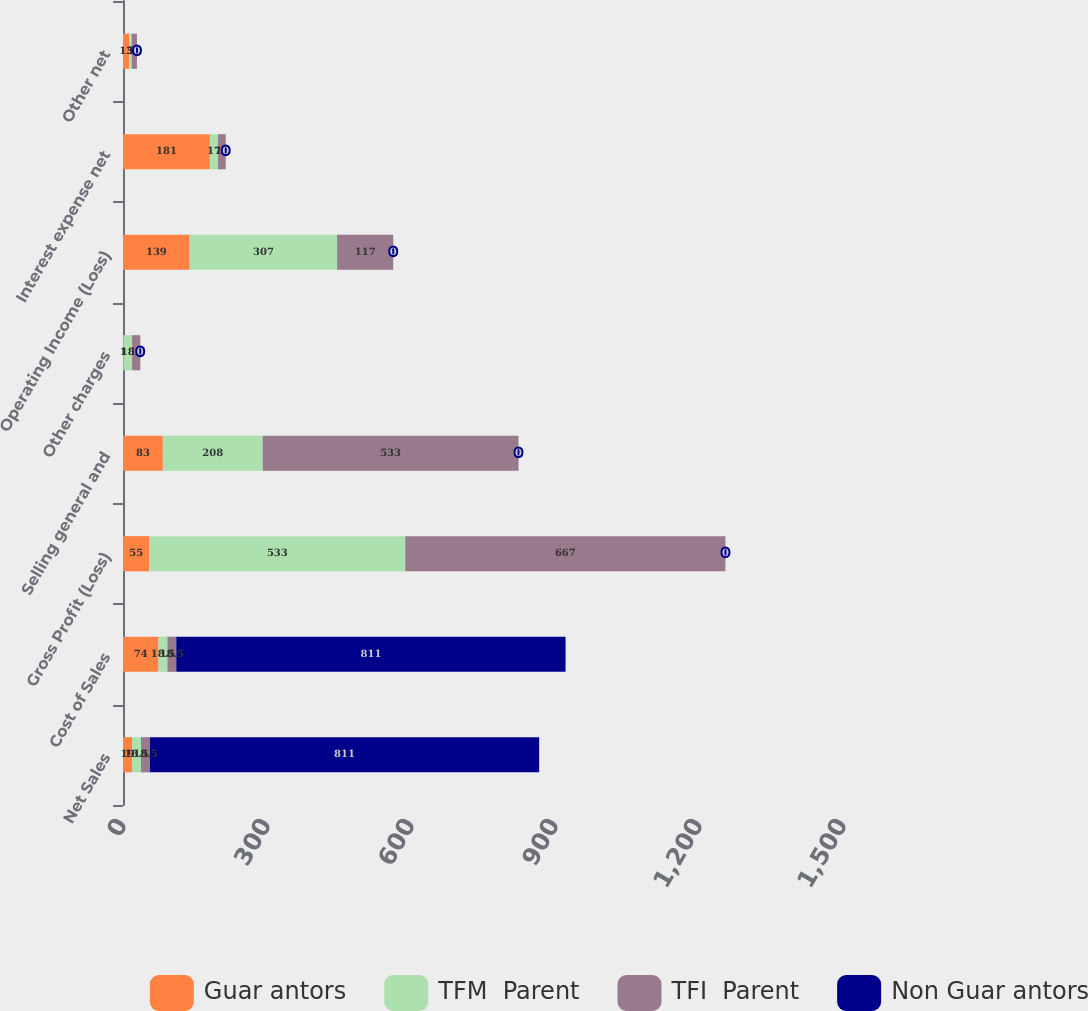<chart> <loc_0><loc_0><loc_500><loc_500><stacked_bar_chart><ecel><fcel>Net Sales<fcel>Cost of Sales<fcel>Gross Profit (Loss)<fcel>Selling general and<fcel>Other charges<fcel>Operating Income (Loss)<fcel>Interest expense net<fcel>Other net<nl><fcel>Guar antors<fcel>19<fcel>74<fcel>55<fcel>83<fcel>1<fcel>139<fcel>181<fcel>13<nl><fcel>TFM  Parent<fcel>18.5<fcel>18.5<fcel>533<fcel>208<fcel>18<fcel>307<fcel>17<fcel>5<nl><fcel>TFI  Parent<fcel>18.5<fcel>18.5<fcel>667<fcel>533<fcel>17<fcel>117<fcel>16<fcel>11<nl><fcel>Non Guar antors<fcel>811<fcel>811<fcel>0<fcel>0<fcel>0<fcel>0<fcel>0<fcel>0<nl></chart> 